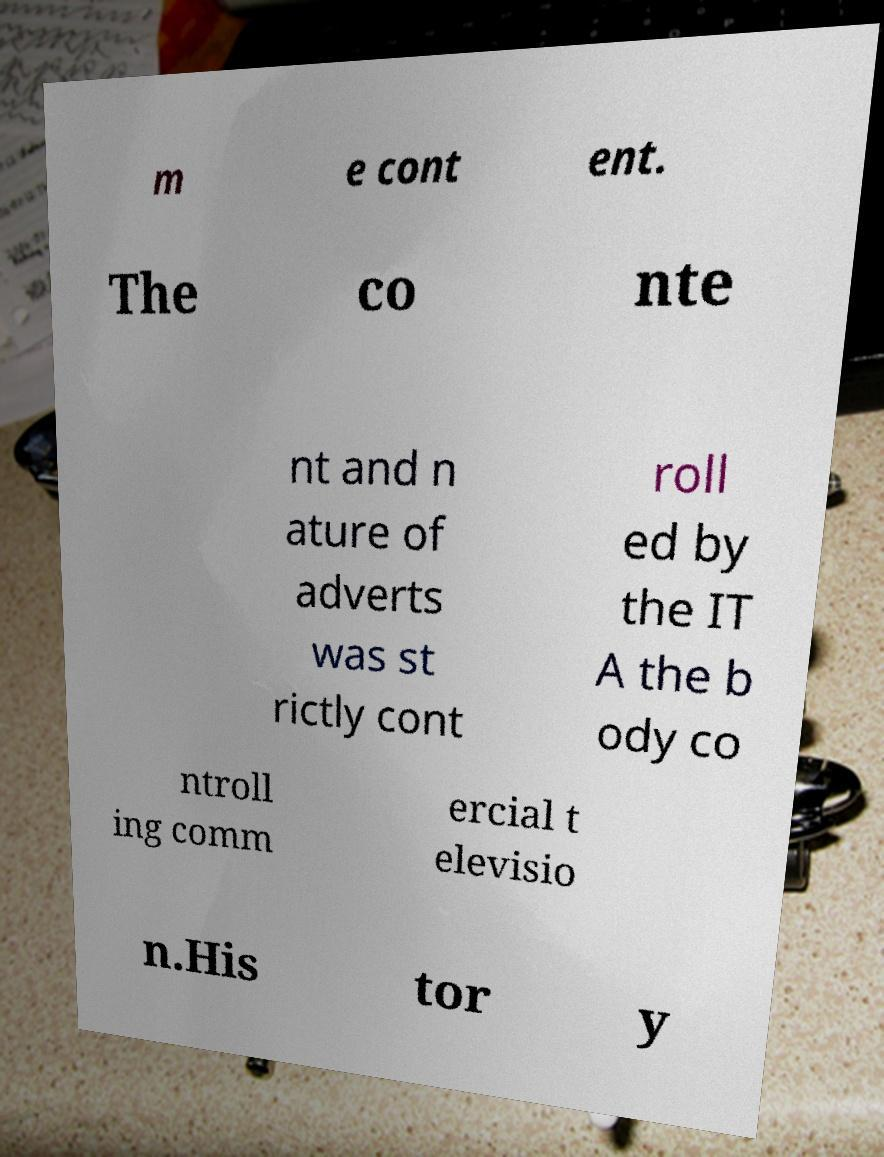I need the written content from this picture converted into text. Can you do that? m e cont ent. The co nte nt and n ature of adverts was st rictly cont roll ed by the IT A the b ody co ntroll ing comm ercial t elevisio n.His tor y 